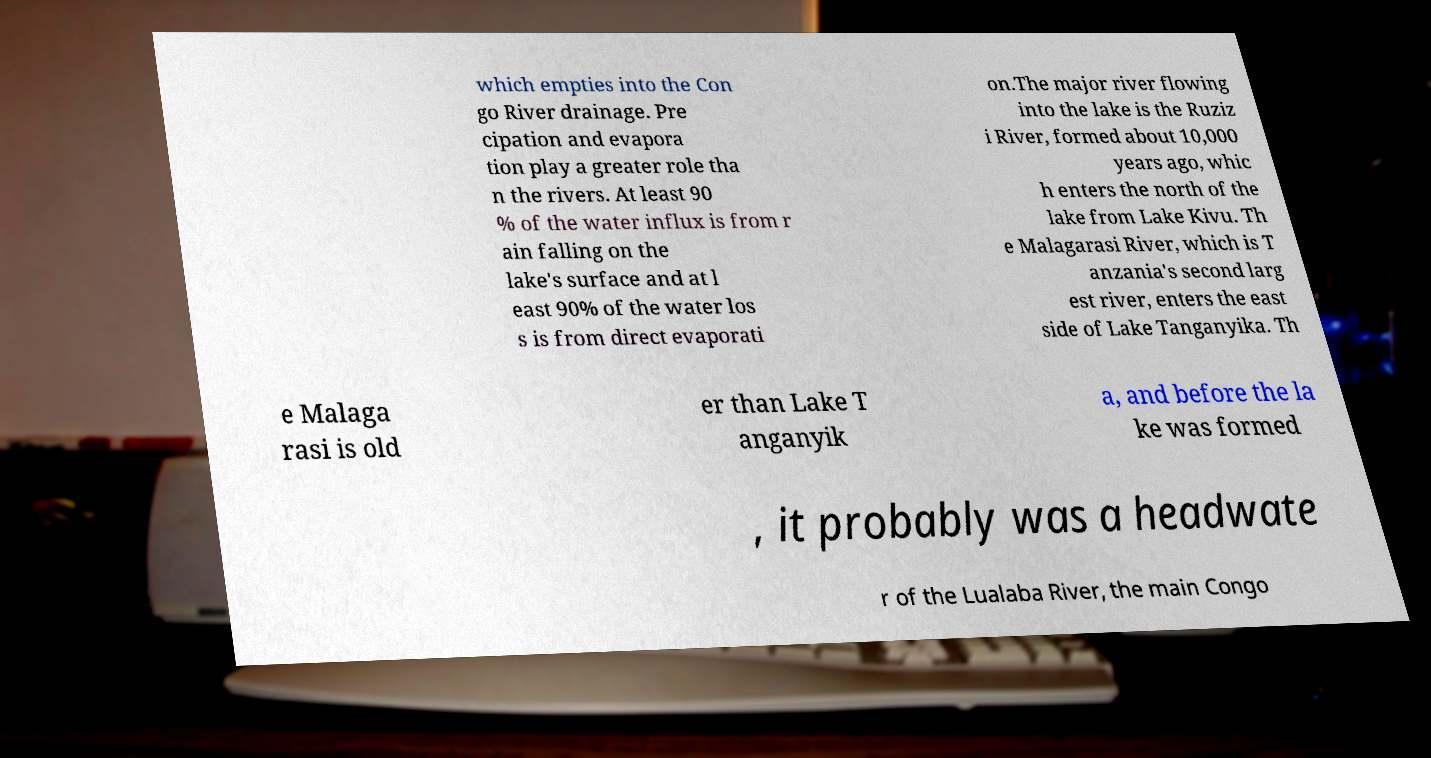Please read and relay the text visible in this image. What does it say? which empties into the Con go River drainage. Pre cipation and evapora tion play a greater role tha n the rivers. At least 90 % of the water influx is from r ain falling on the lake's surface and at l east 90% of the water los s is from direct evaporati on.The major river flowing into the lake is the Ruziz i River, formed about 10,000 years ago, whic h enters the north of the lake from Lake Kivu. Th e Malagarasi River, which is T anzania's second larg est river, enters the east side of Lake Tanganyika. Th e Malaga rasi is old er than Lake T anganyik a, and before the la ke was formed , it probably was a headwate r of the Lualaba River, the main Congo 